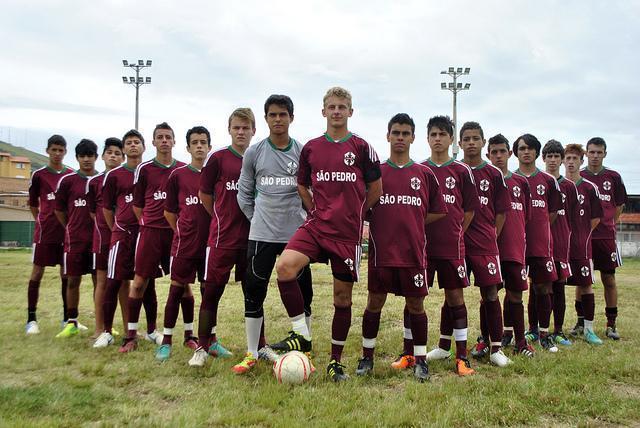How many people are there?
Give a very brief answer. 14. How many birds are on the left windowsill?
Give a very brief answer. 0. 